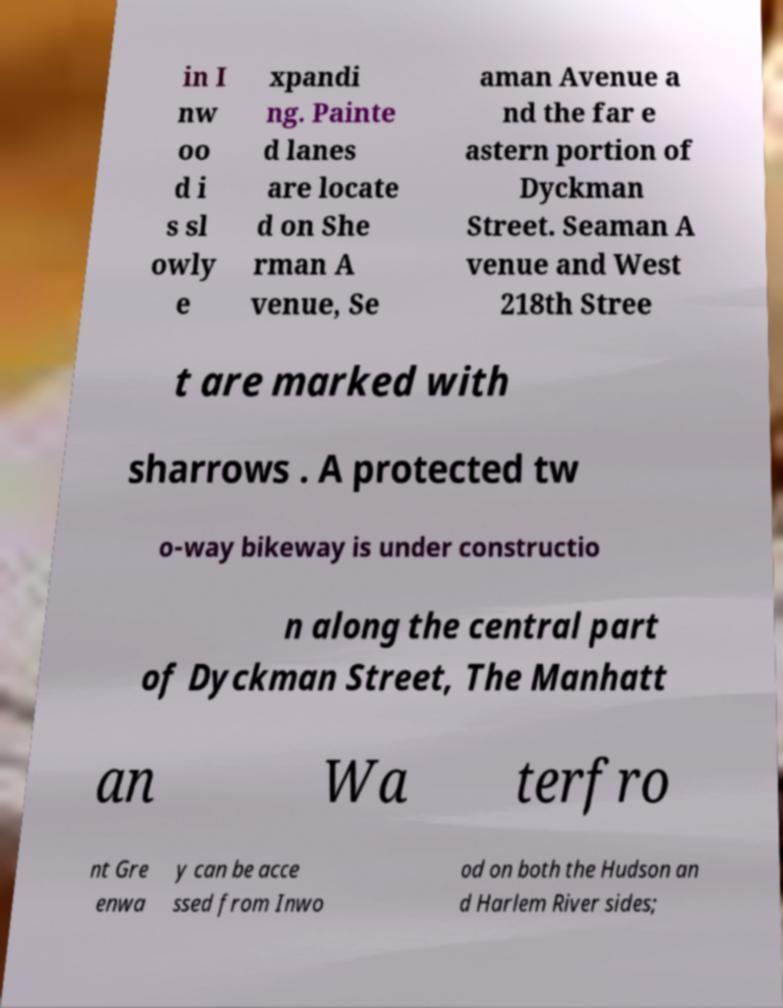Can you accurately transcribe the text from the provided image for me? in I nw oo d i s sl owly e xpandi ng. Painte d lanes are locate d on She rman A venue, Se aman Avenue a nd the far e astern portion of Dyckman Street. Seaman A venue and West 218th Stree t are marked with sharrows . A protected tw o-way bikeway is under constructio n along the central part of Dyckman Street, The Manhatt an Wa terfro nt Gre enwa y can be acce ssed from Inwo od on both the Hudson an d Harlem River sides; 